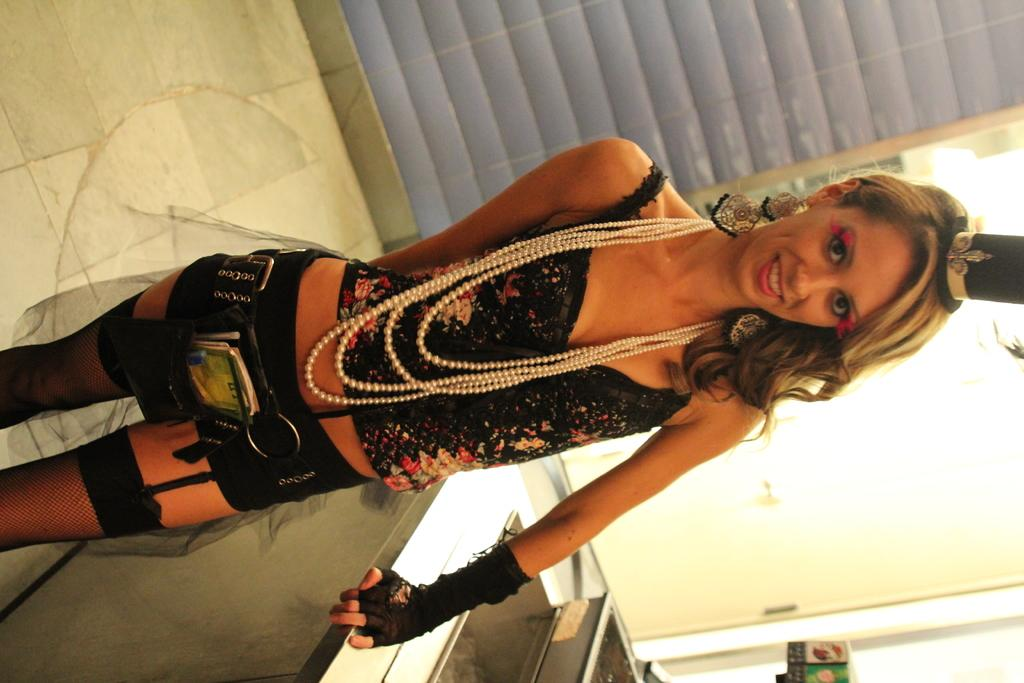Who is the main subject in the image? There is a woman in the image. Where is the woman located in the image? The woman is in the middle of the image. What can be seen in the background of the image? There is a wall in the background of the image. What is present at the bottom of the image? There is an object present at the bottom of the image. What type of battle is taking place in the image? There is no battle present in the image; it features a woman in the middle of the image with a wall in the background and an object at the bottom. Can you tell me how many hydrants are visible in the image? There are no hydrants present in the image. 